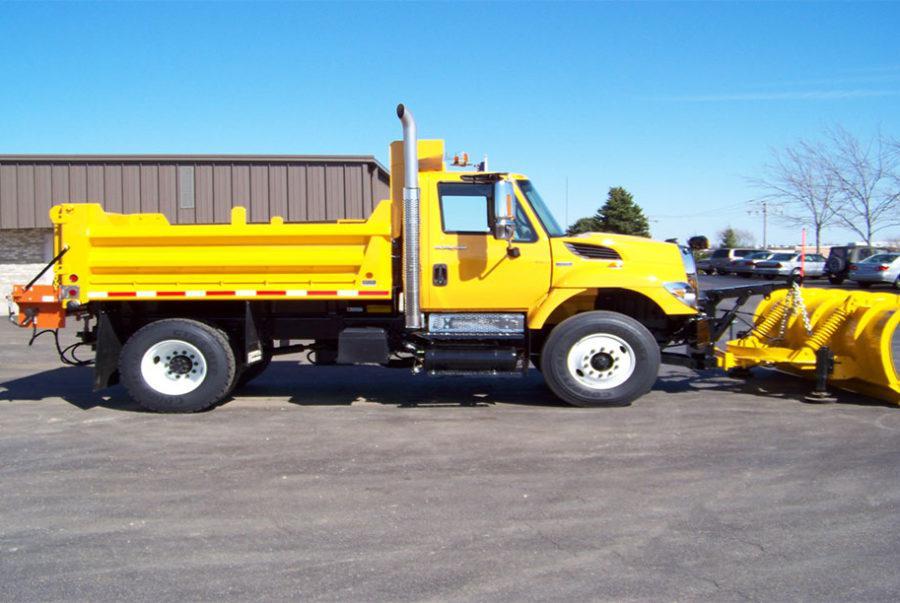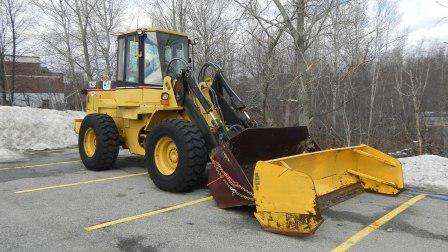The first image is the image on the left, the second image is the image on the right. Examine the images to the left and right. Is the description "There is a snowplow on a snow-covered surface." accurate? Answer yes or no. No. The first image is the image on the left, the second image is the image on the right. Considering the images on both sides, is "There is snow in the image on the left." valid? Answer yes or no. No. 